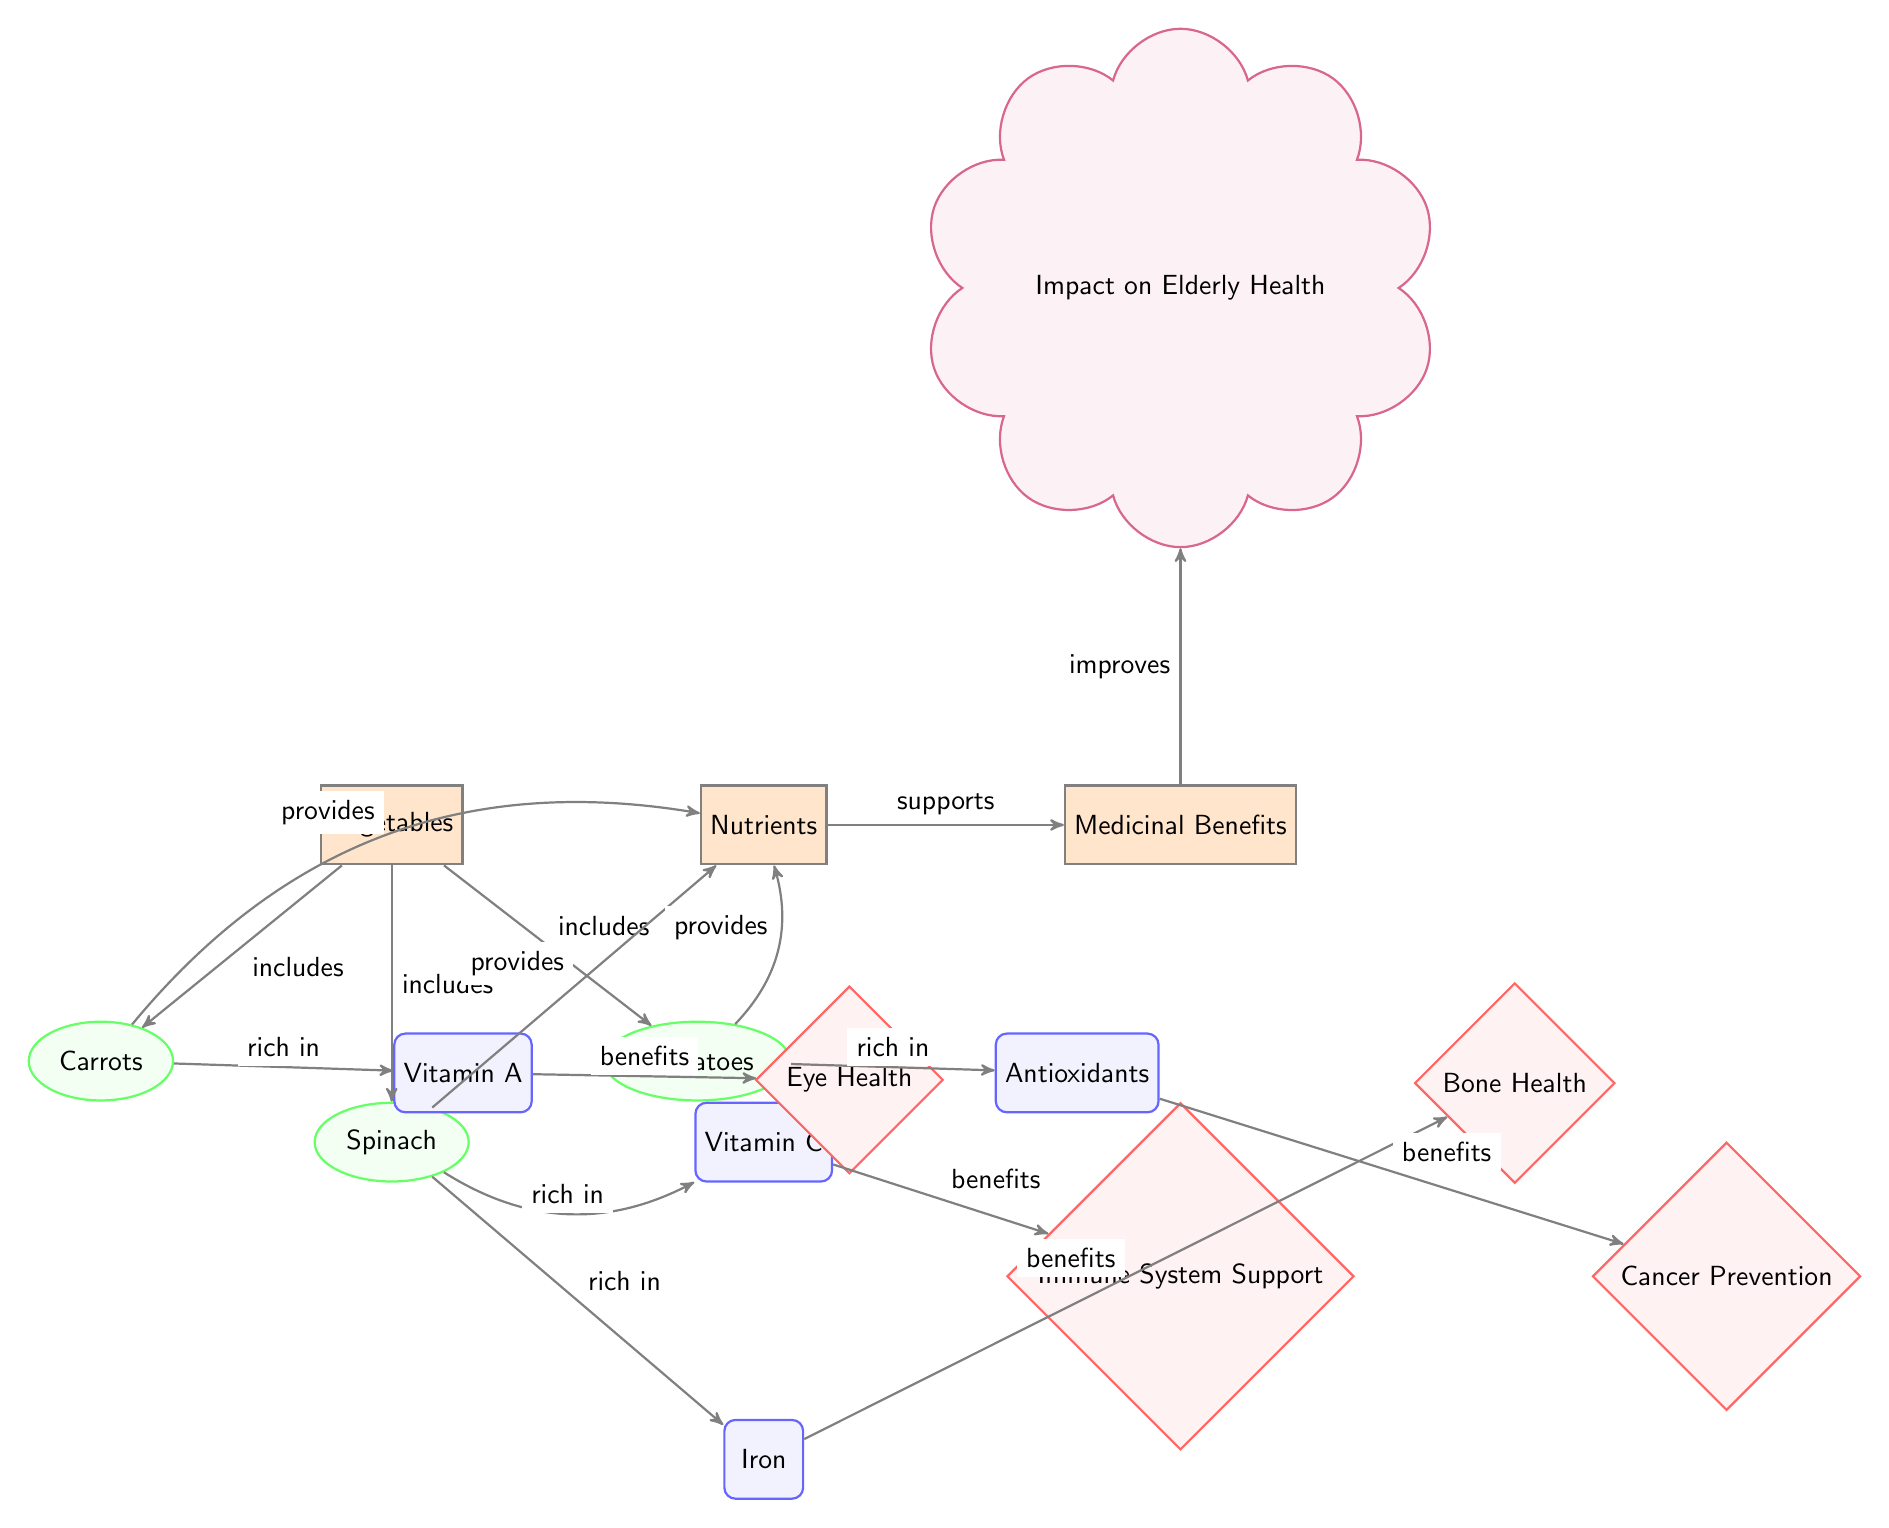What vegetables are included in the diagram? The diagram lists three vegetables, which are shown in the "Vegetables" category node. These are carrots, spinach, and tomatoes.
Answer: carrots, spinach, tomatoes How many main categories are represented in the diagram? The diagram contains four main categories: Vegetables, Nutrients, Medicinal Benefits, and Impact on Elderly Health. Counting these, we find there are four categories total.
Answer: 4 Which nutrient is spinach rich in? In the diagram, spinach is connected to two nutrient nodes: iron and vitamin C. It is noted that spinach is particularly rich in iron.
Answer: iron What medicinal benefit is associated with vitamin A? The diagram shows that vitamin A directly connects to the benefit of Eye Health. Therefore, the medicinal benefit associated with vitamin A is eye health.
Answer: Eye Health Which vegetable is rich in antioxidants? According to the diagram, tomatoes are specifically noted for being rich in antioxidants. Therefore, the answer is tomatoes.
Answer: tomatoes What is the impact of increased nutrient intake on elderly health according to the diagram? The diagram states that the benefits derived from nutrients support improvements in elderly health. Since the connection from benefits to impact is established, we can say that these improvements positively impact elderly health.
Answer: improves How does iron support elderly health? Iron is linked to the medicinal benefit of Bone Health in the diagram. Therefore, it supports elderly health through this specific benefit.
Answer: Bone Health Which nutrient is responsible for Cancer Prevention? The diagram indicates that antioxidants provide the benefit of Cancer Prevention. Therefore, the nutrient responsible for this benefit is antioxidants.
Answer: Antioxidants 